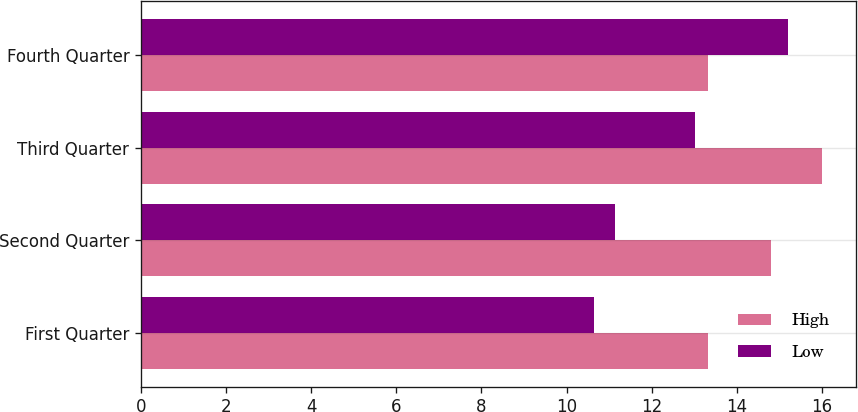Convert chart to OTSL. <chart><loc_0><loc_0><loc_500><loc_500><stacked_bar_chart><ecel><fcel>First Quarter<fcel>Second Quarter<fcel>Third Quarter<fcel>Fourth Quarter<nl><fcel>High<fcel>13.32<fcel>14.8<fcel>16<fcel>13.32<nl><fcel>Low<fcel>10.64<fcel>11.14<fcel>13.02<fcel>15.2<nl></chart> 